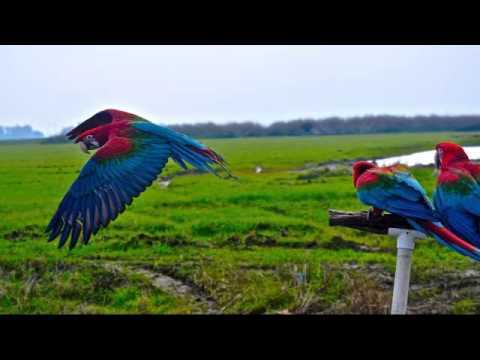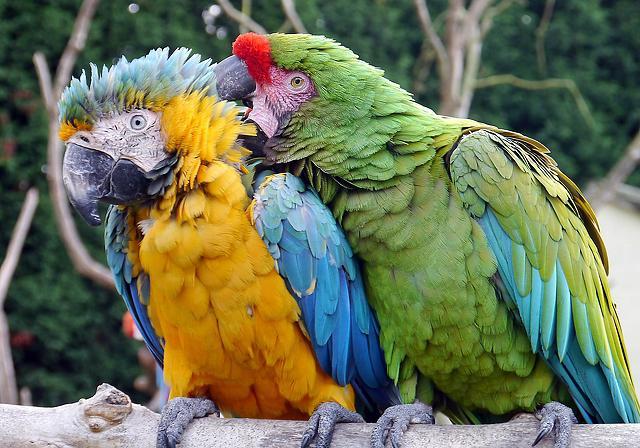The first image is the image on the left, the second image is the image on the right. Considering the images on both sides, is "Both bird in the image on the left are perched on a branch." valid? Answer yes or no. No. The first image is the image on the left, the second image is the image on the right. Given the left and right images, does the statement "An image shows a bird perched on a person's extended hand." hold true? Answer yes or no. No. 